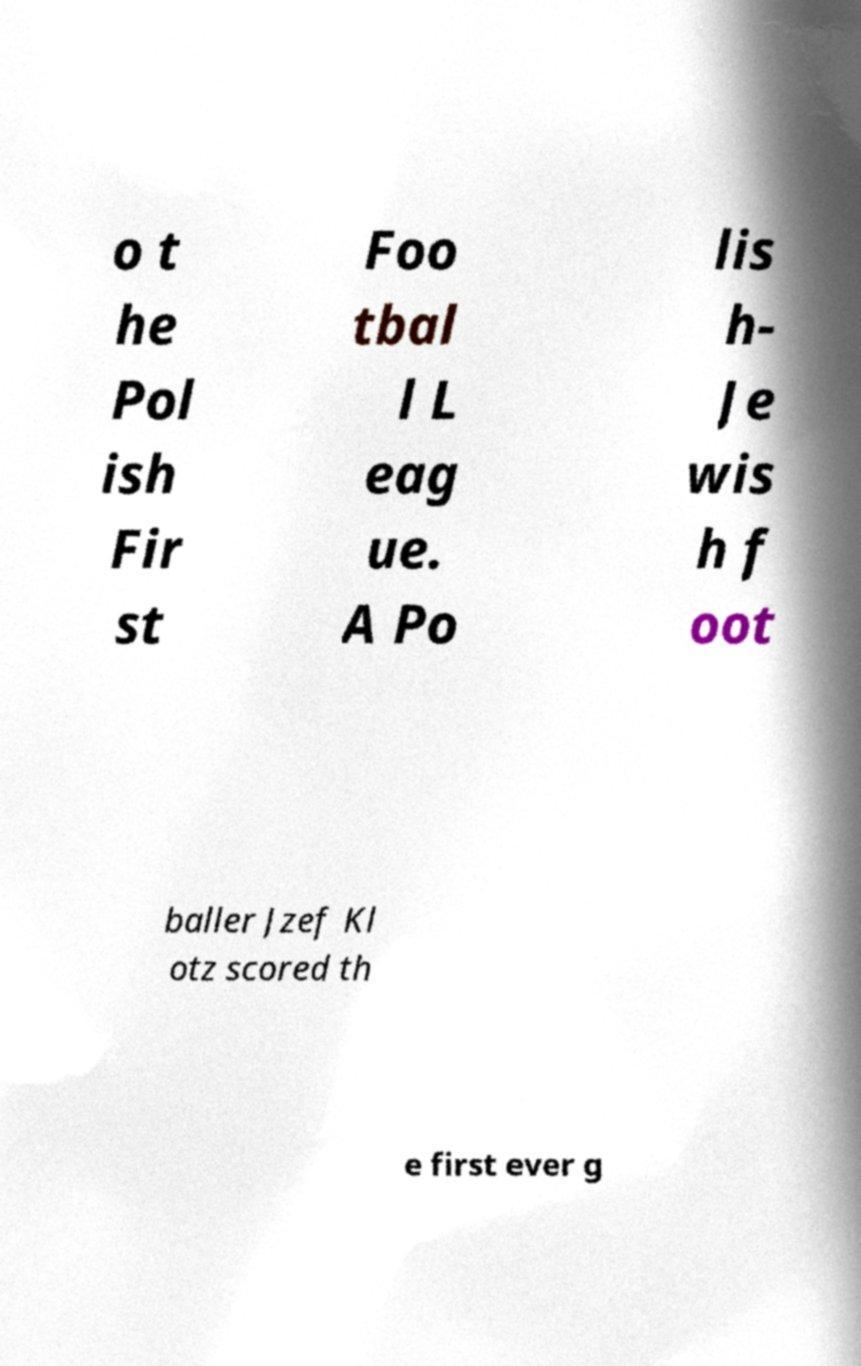Can you accurately transcribe the text from the provided image for me? o t he Pol ish Fir st Foo tbal l L eag ue. A Po lis h- Je wis h f oot baller Jzef Kl otz scored th e first ever g 